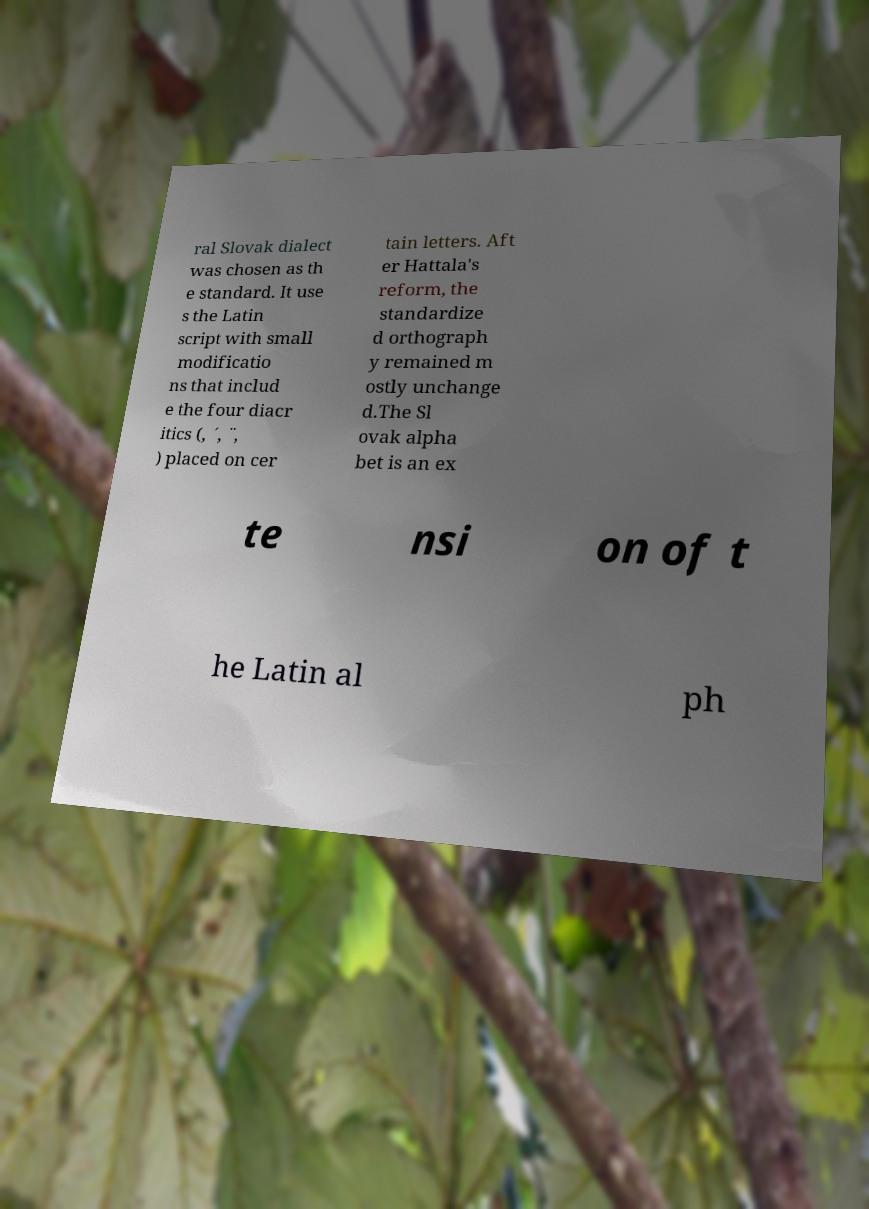Please read and relay the text visible in this image. What does it say? ral Slovak dialect was chosen as th e standard. It use s the Latin script with small modificatio ns that includ e the four diacr itics (, ´, ¨, ) placed on cer tain letters. Aft er Hattala's reform, the standardize d orthograph y remained m ostly unchange d.The Sl ovak alpha bet is an ex te nsi on of t he Latin al ph 